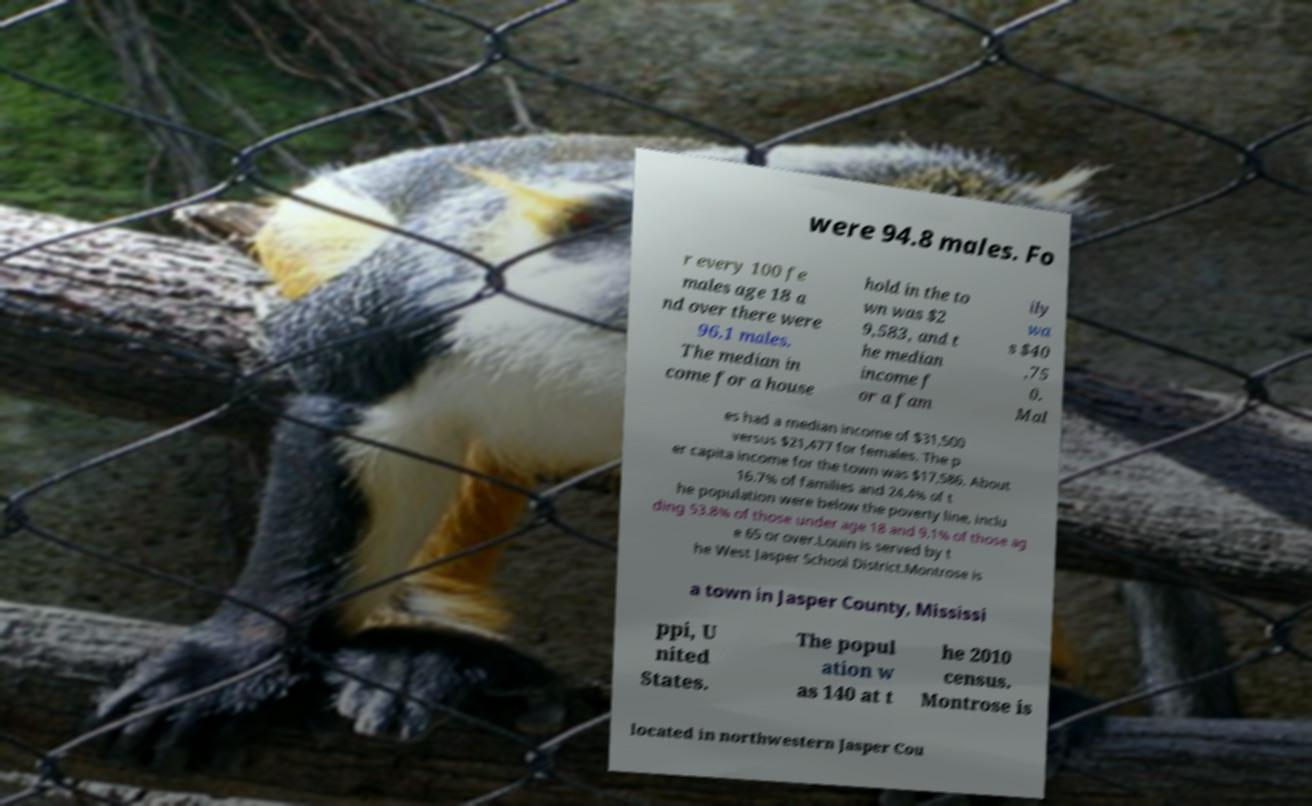Please identify and transcribe the text found in this image. were 94.8 males. Fo r every 100 fe males age 18 a nd over there were 96.1 males. The median in come for a house hold in the to wn was $2 9,583, and t he median income f or a fam ily wa s $40 ,75 0. Mal es had a median income of $31,500 versus $21,477 for females. The p er capita income for the town was $17,586. About 16.7% of families and 24.4% of t he population were below the poverty line, inclu ding 53.8% of those under age 18 and 9.1% of those ag e 65 or over.Louin is served by t he West Jasper School District.Montrose is a town in Jasper County, Mississi ppi, U nited States. The popul ation w as 140 at t he 2010 census. Montrose is located in northwestern Jasper Cou 